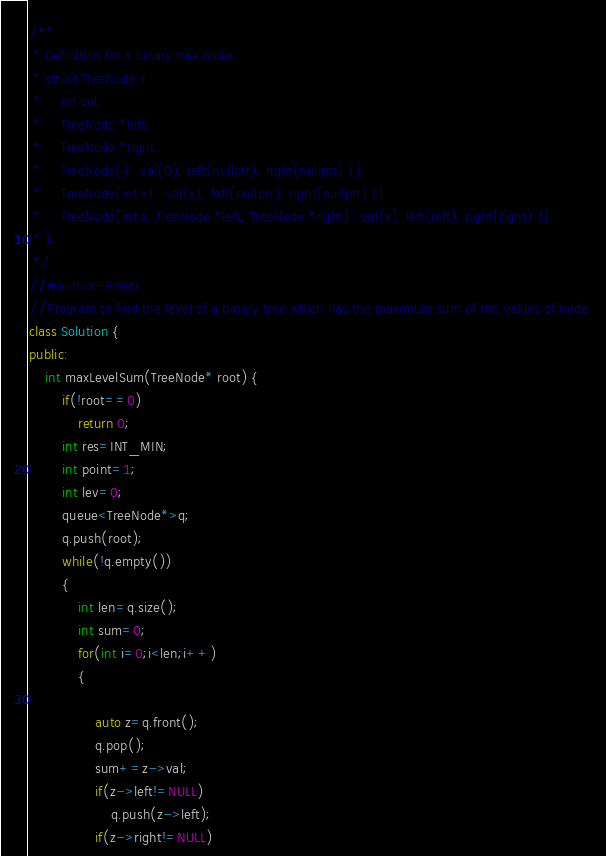<code> <loc_0><loc_0><loc_500><loc_500><_C++_>/**
 * Definition for a binary tree node.
 * struct TreeNode {
 *     int val;
 *     TreeNode *left;
 *     TreeNode *right;
 *     TreeNode() : val(0), left(nullptr), right(nullptr) {}
 *     TreeNode(int x) : val(x), left(nullptr), right(nullptr) {}
 *     TreeNode(int x, TreeNode *left, TreeNode *right) : val(x), left(left), right(right) {}
 * };
 */
//#author-Preeti
//Program to find the level of a binary tree which has the maximum sum of the values of node.
class Solution {
public:
    int maxLevelSum(TreeNode* root) {
        if(!root==0)
            return 0;
        int res=INT_MIN;
        int point=1;
        int lev=0;
        queue<TreeNode*>q;
        q.push(root);
        while(!q.empty())
        {
            int len=q.size();
            int sum=0;
            for(int i=0;i<len;i++)
            {
                
                auto z=q.front();
                q.pop();
                sum+=z->val;
                if(z->left!=NULL)
                    q.push(z->left);
                if(z->right!=NULL)</code> 